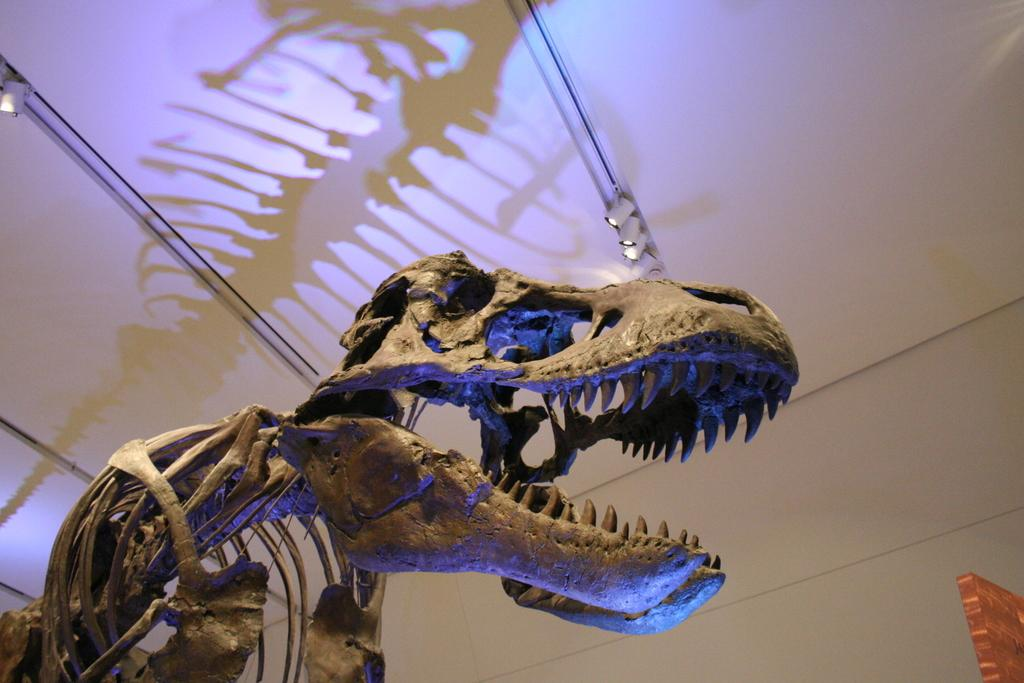What is the main subject of the image? There is a skeleton of an ancient animal in the image. What can be seen above the skeleton in the image? There is a ceiling visible in the image, and lights are attached to it. What is in the background of the image? There is a wall in the background of the image, and there is a brown-colored object present. How many geese are sitting on the sofa in the image? There are no geese or sofa present in the image. What type of waste can be seen in the background of the image? There is no waste visible in the image; it only features a wall and a brown-colored object in the background. 